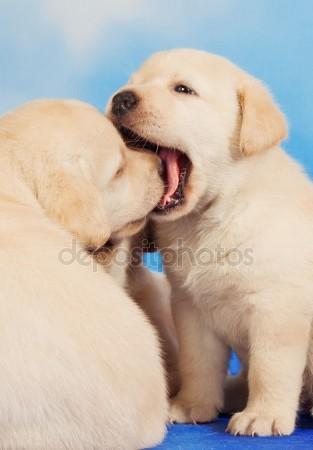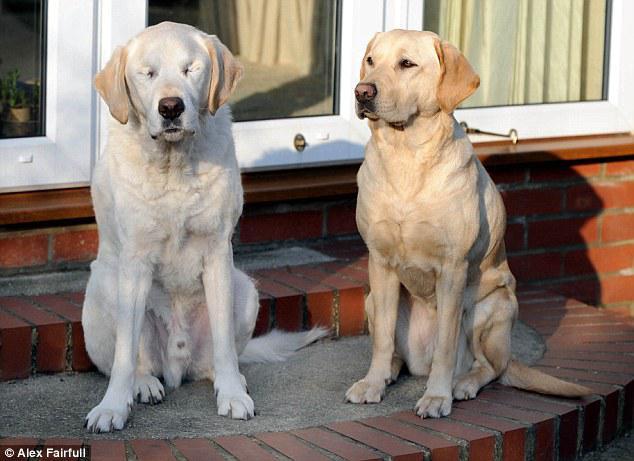The first image is the image on the left, the second image is the image on the right. Evaluate the accuracy of this statement regarding the images: "The left image contains one dog laying on wooden flooring.". Is it true? Answer yes or no. No. The first image is the image on the left, the second image is the image on the right. Evaluate the accuracy of this statement regarding the images: "Each image contains one dog, and every dog is a """"blond"""" puppy.". Is it true? Answer yes or no. No. 